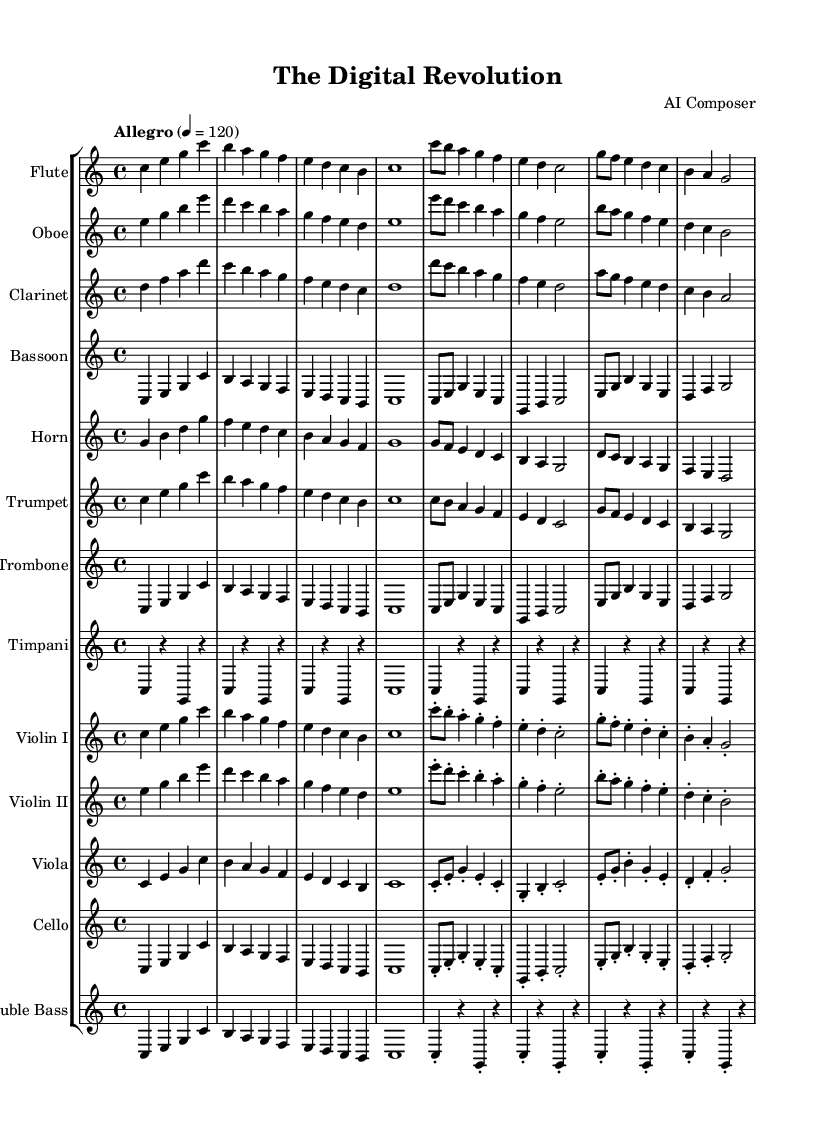What is the key signature of this music? The key signature is C major, which has no sharps or flats.
Answer: C major What is the time signature of this piece? The time signature is presented as 4/4, indicating four beats per measure.
Answer: 4/4 What is the tempo marking for the piece? The tempo marking indicates "Allegro" with a metronome marking of quarter note = 120 beats per minute.
Answer: Allegro How many different instruments are featured in this symphony? The score lists a total of 13 different instruments as indicated by the number of staff groups.
Answer: 13 Which thematic section is abbreviated in the notation provided? The notation specifically mentions "Theme A" as being abbreviated, referring to the main theme of the composition.
Answer: Theme A How is the introduction characterized in terms of tempo and rhythm? The introduction is set to the same allegro tempo, allowing for a lively and brisk entry before the formal theme is presented.
Answer: Allegro Identify one woodwind instrument present in the score. The score explicitly lists flute as one of the woodwind instruments included in the orchestration.
Answer: Flute 